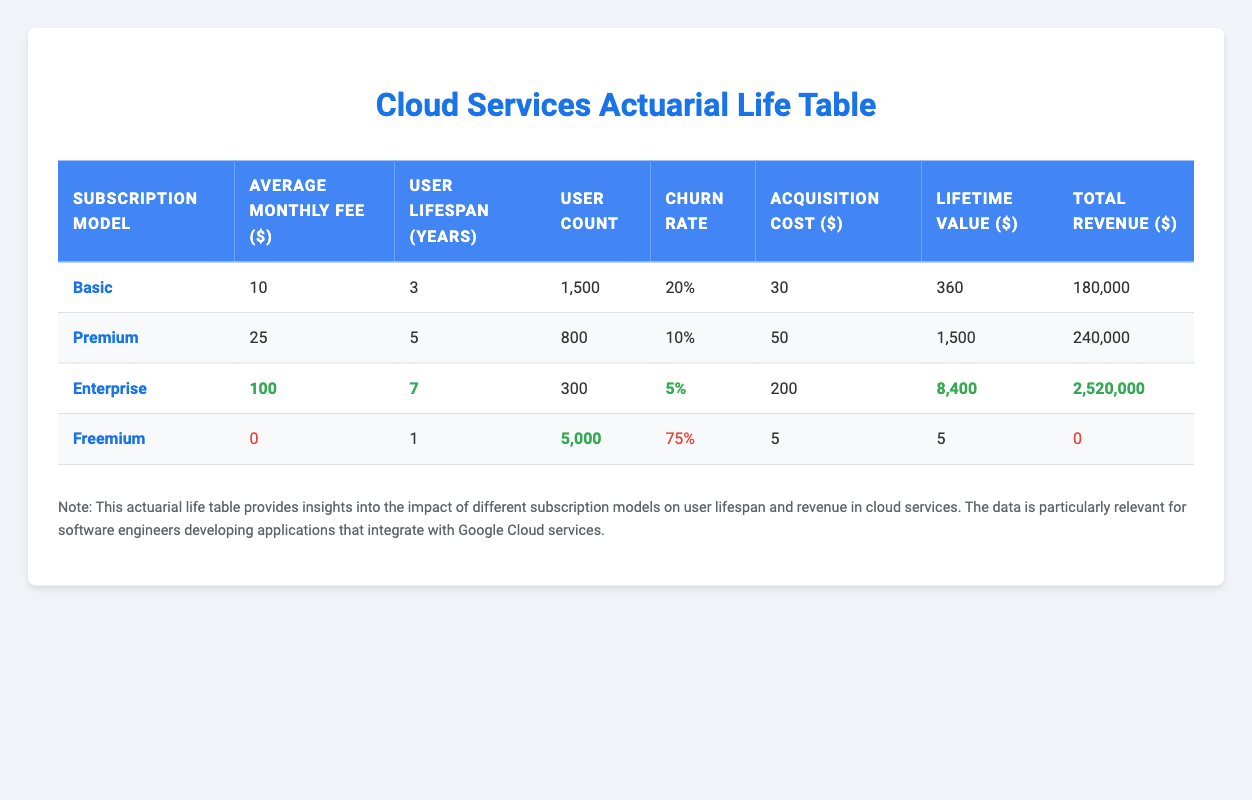What is the user lifespan for the enterprise subscription model? The table indicates that the user lifespan for the enterprise subscription model is directly listed under the "User Lifespan (Years)" column. It shows 7 years.
Answer: 7 years What is the total revenue generated by the premium subscription model? The total revenue for the premium subscription model is recorded in the "Total Revenue ($)" column, which shows 240,000.
Answer: 240,000 Which subscription model has the highest average churn rate? The "Average Churn Rate" column provides the churn rates for each model. By comparing the values, the freemium model has the highest churn rate at 75%.
Answer: Freemium How much more does the enterprise model earn in total revenue compared to the basic model? The total revenue for the enterprise model is 2,520,000 and for the basic model, it is 180,000. To find the difference, subtract 180,000 from 2,520,000, which equals 2,340,000.
Answer: 2,340,000 Is the average monthly fee for the freemium model more than the basic model? The average monthly fee for the freemium model is listed as 0, and for the basic model, it is 10. Since 0 is not greater than 10, the statement is false.
Answer: No What is the average lifetime value for users of the basic subscription model? The table lists the average lifetime value under "Lifetime Value ($)." For the basic model, it shows 360.
Answer: 360 Which subscription model has the lowest user count? The user count is listed under "User Count" column. The enterprise model has 300 users, which is the lowest compared to the other models.
Answer: Enterprise What is the combined average monthly fee of all subscription models? The average monthly fees from the table are 10 for basic, 25 for premium, 100 for enterprise, and 0 for freemium. Summing these gives 10 + 25 + 100 + 0 = 135, and dividing by 4 models gives an average of 33.75.
Answer: 33.75 What percentage of total revenue does the premium model contribute relative to the total revenue of all models? The total revenue for all models is 3,000,000 (180,000 + 240,000 + 2,520,000 + 0). The premium model contributes 240,000. To find the percentage: (240,000 / 3,000,000) * 100 = 8%.
Answer: 8% 